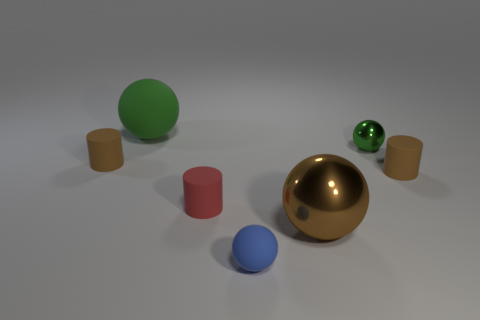Subtract all tiny brown rubber cylinders. How many cylinders are left? 1 Add 1 small brown matte objects. How many objects exist? 8 Subtract all cylinders. How many objects are left? 4 Subtract all red cylinders. How many cylinders are left? 2 Add 5 tiny green objects. How many tiny green objects exist? 6 Subtract 1 red cylinders. How many objects are left? 6 Subtract all red spheres. Subtract all red cubes. How many spheres are left? 4 Subtract all brown cubes. How many green spheres are left? 2 Subtract all gray blocks. Subtract all small brown cylinders. How many objects are left? 5 Add 3 green shiny spheres. How many green shiny spheres are left? 4 